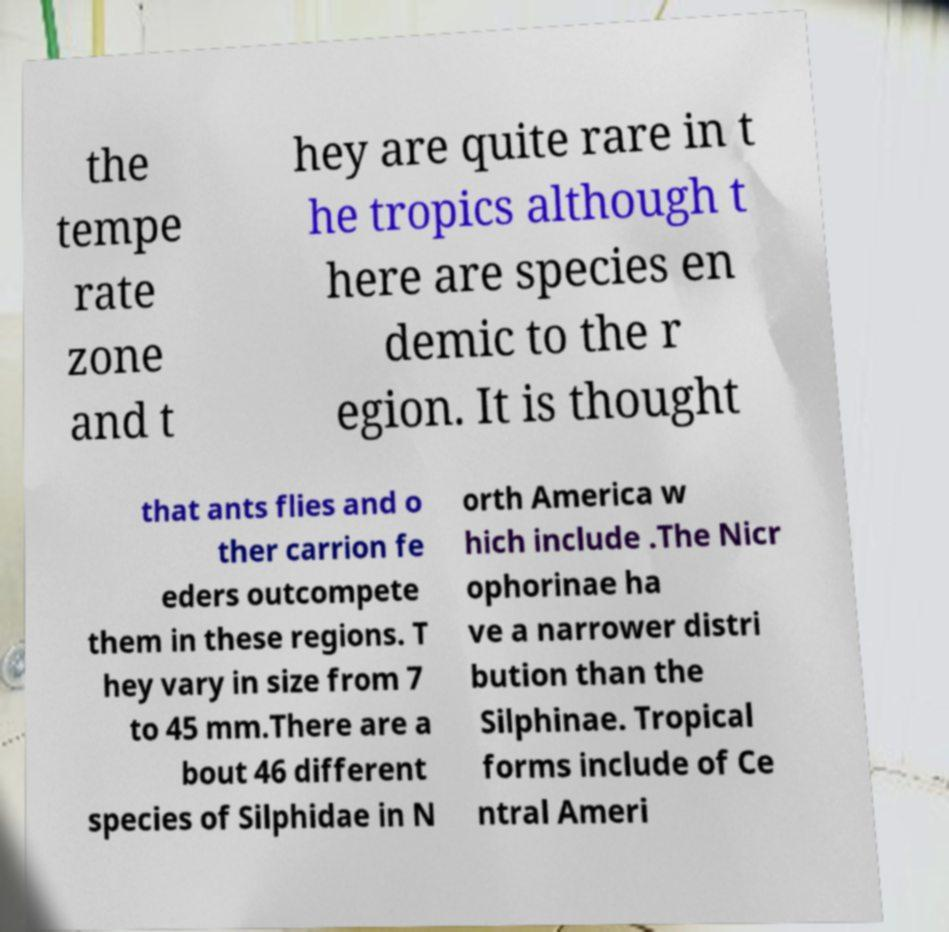I need the written content from this picture converted into text. Can you do that? the tempe rate zone and t hey are quite rare in t he tropics although t here are species en demic to the r egion. It is thought that ants flies and o ther carrion fe eders outcompete them in these regions. T hey vary in size from 7 to 45 mm.There are a bout 46 different species of Silphidae in N orth America w hich include .The Nicr ophorinae ha ve a narrower distri bution than the Silphinae. Tropical forms include of Ce ntral Ameri 